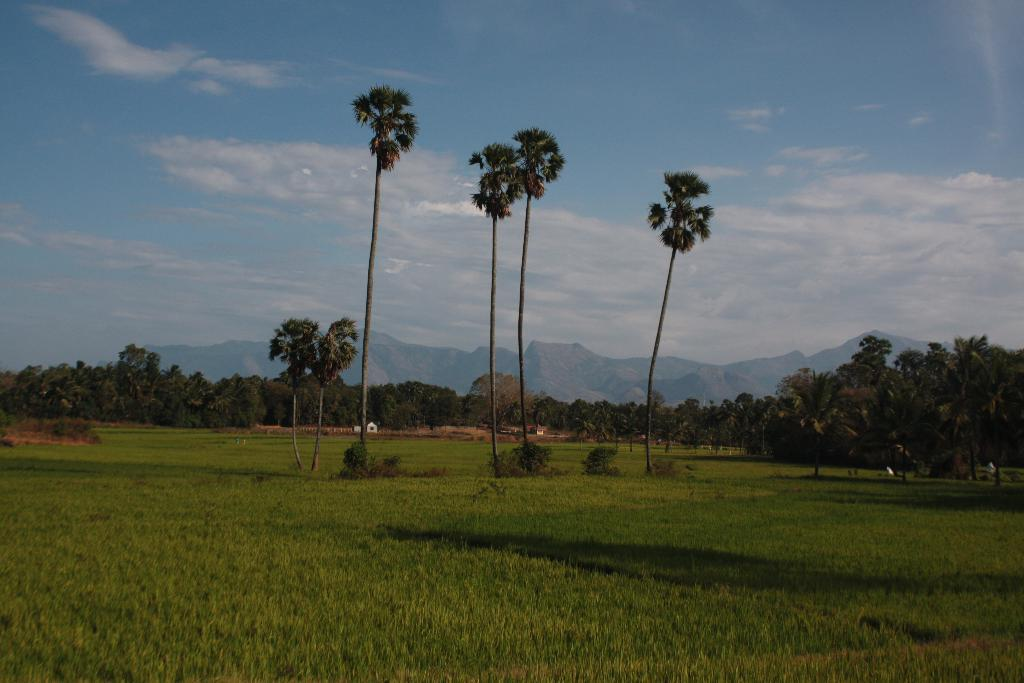What type of vegetation can be seen at the bottom of the image? There are crops at the bottom of the image. What can be seen in the distance behind the crops? There are trees and mountains in the background of the image. What is visible in the sky in the image? There are clouds in the sky. What is the condition of the sky in the image? The sky is visible in the background of the image, and there are clouds present. What type of jelly is being stored on the shelf in the image? There is no shelf or jelly present in the image. What is the current weather condition in the image? The image does not provide information about the weather condition; it only shows crops, trees, mountains, and clouds in the sky. 